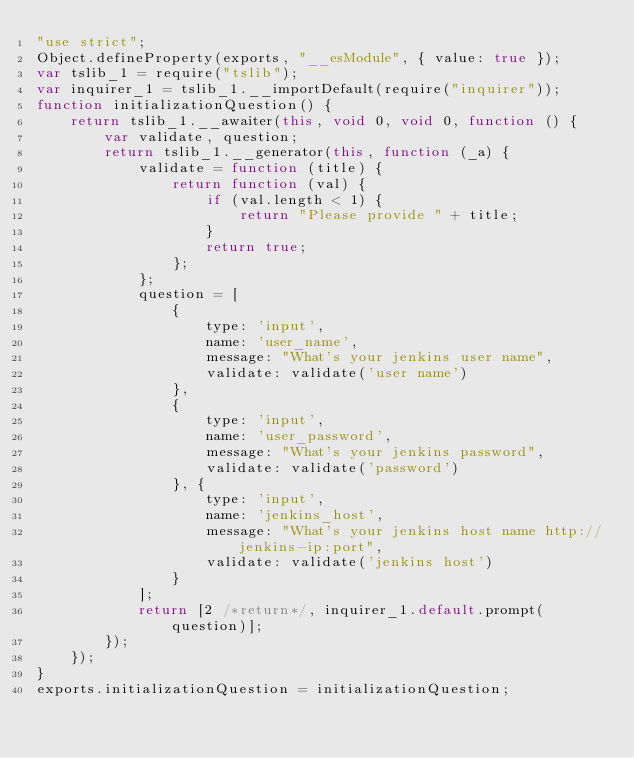Convert code to text. <code><loc_0><loc_0><loc_500><loc_500><_JavaScript_>"use strict";
Object.defineProperty(exports, "__esModule", { value: true });
var tslib_1 = require("tslib");
var inquirer_1 = tslib_1.__importDefault(require("inquirer"));
function initializationQuestion() {
    return tslib_1.__awaiter(this, void 0, void 0, function () {
        var validate, question;
        return tslib_1.__generator(this, function (_a) {
            validate = function (title) {
                return function (val) {
                    if (val.length < 1) {
                        return "Please provide " + title;
                    }
                    return true;
                };
            };
            question = [
                {
                    type: 'input',
                    name: 'user_name',
                    message: "What's your jenkins user name",
                    validate: validate('user name')
                },
                {
                    type: 'input',
                    name: 'user_password',
                    message: "What's your jenkins password",
                    validate: validate('password')
                }, {
                    type: 'input',
                    name: 'jenkins_host',
                    message: "What's your jenkins host name http://jenkins-ip:port",
                    validate: validate('jenkins host')
                }
            ];
            return [2 /*return*/, inquirer_1.default.prompt(question)];
        });
    });
}
exports.initializationQuestion = initializationQuestion;
</code> 